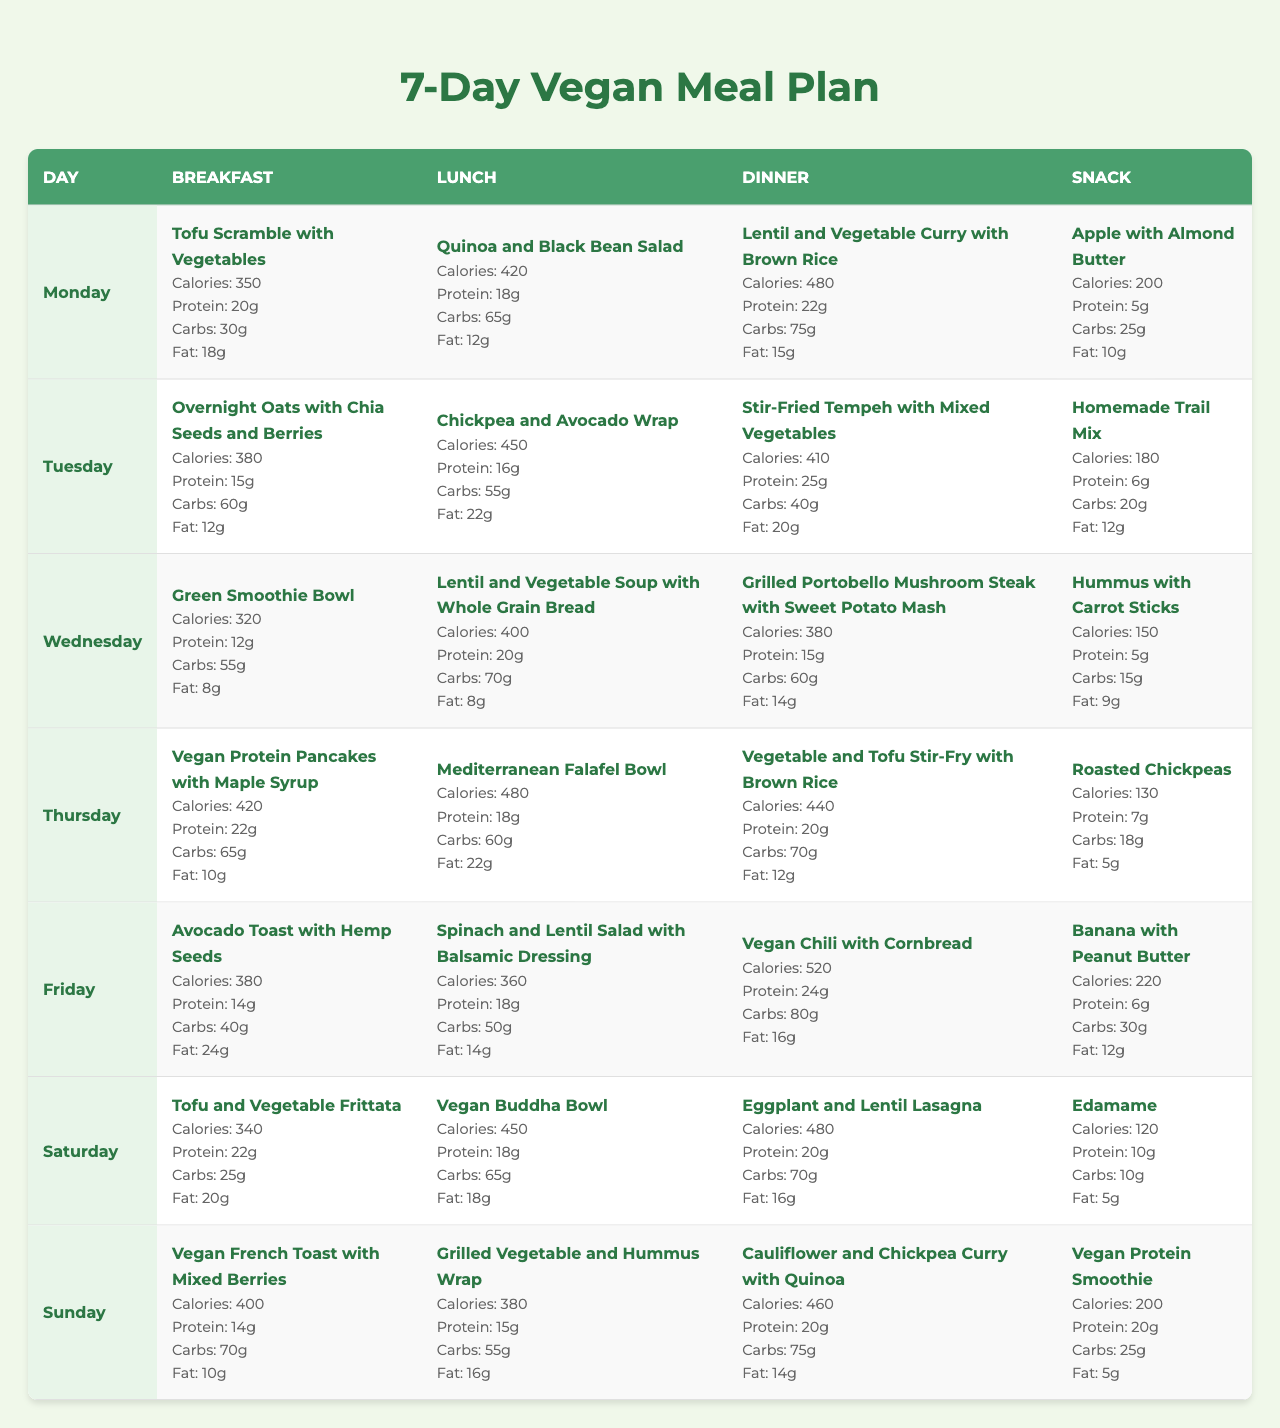What are the total calories for lunch on Thursday? The lunch on Thursday consists of a Mediterranean Falafel Bowl which has 480 calories.
Answer: 480 Which meal contains the highest amount of protein on Monday? The highest protein meal on Monday is the dinner, which is Lentil and Vegetable Curry with Brown Rice, providing 22g of protein.
Answer: 22g What is the average calorie intake for breakfast over the week? The daily breakfast calories are: 350, 380, 320, 420, 380, 340, 400. Summing these gives 350 + 380 + 320 + 420 + 380 + 340 + 400 = 2,590 calories. Dividing this by 7 days gives an average of 2,590 / 7 ≈ 370 calories.
Answer: Approximately 370 Is there a day where the total calorie intake exceeds 1,800 calories? Adding up all daily meal calories for Saturday: 340 (breakfast) + 450 (lunch) + 480 (dinner) + 120 (snack) = 1,390 calories; which is less than 1,800. Continuing to check Sunday, 400 + 380 + 460 + 200 = 1,440, which is also less. All days remain under 1,800 calories.
Answer: No What is the total amount of carbs consumed for dinner on all days? The dinner carbs are: 75 (Monday) + 40 (Tuesday) + 60 (Wednesday) + 70 (Thursday) + 80 (Friday) + 70 (Saturday) + 75 (Sunday). Summing gives 75 + 40 + 60 + 70 + 80 + 70 + 75 = 470g of carbs.
Answer: 470g Which meal on Tuesday has the highest calorie count? On Tuesday, lunch has the highest calorie count with the Chickpea and Avocado Wrap totaling 450 calories compared to the other meals: 380 (breakfast), 410 (dinner), and 180 (snack).
Answer: 450 How many grams of fat are consumed in total from snacks throughout the week? The snacks contain: 10 (Monday) + 12 (Tuesday) + 9 (Wednesday) + 5 (Thursday) + 12 (Friday) + 5 (Saturday) + 5 (Sunday). Summing provides 10 + 12 + 9 + 5 + 12 + 5 + 5 = 58g of fat consumed.
Answer: 58g Which day has the highest total protein intake from all meals? Calculating the total protein for each day: Monday: 20+18+22+5=65, Tuesday: 15+16+25+6=62, Wednesday: 12+20+15+5=52, Thursday: 22+18+20+7=67, Friday: 14+18+24+6=62, Saturday: 22+18+20+10=70, Sunday: 14+15+20+20=69. Highest is Thursday with 67g.
Answer: Thursday What percentage of total calories for the week comes from breakfast? The total weekly breakfast calories is 2,590 and the total weekly calories is calculated by summing up all meals (Monday: 1,480, Tuesday: 1,420, Wednesday: 1,370, Thursday: 1,605, Friday: 1,480, Saturday: 1,390, Sunday: 1,440) = 10,485. So, (2,590 / 10,485) * 100 ≈ 24.7%.
Answer: Approximately 24.7% Is there any meal across the week that contains exactly 200 calories? Only the snack on Sunday (Vegan Protein Smoothie) contains 200 calories, we check other meals and find none else at that value.
Answer: Yes 